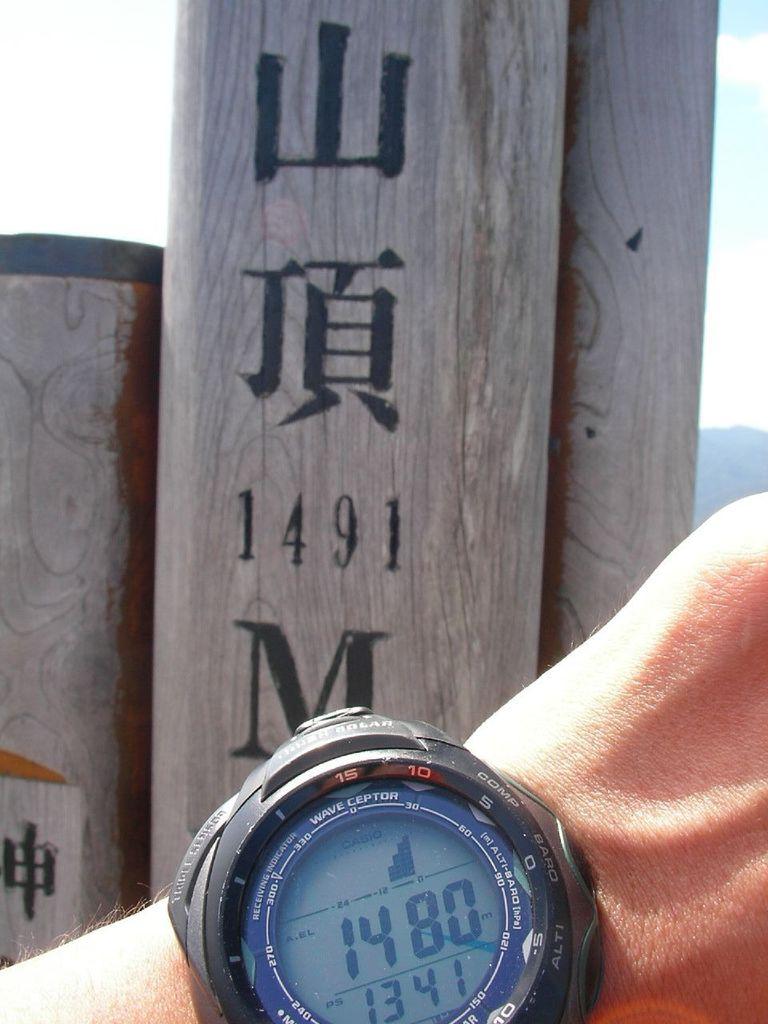What elevation number is written on the post?
Offer a terse response. 1491. 